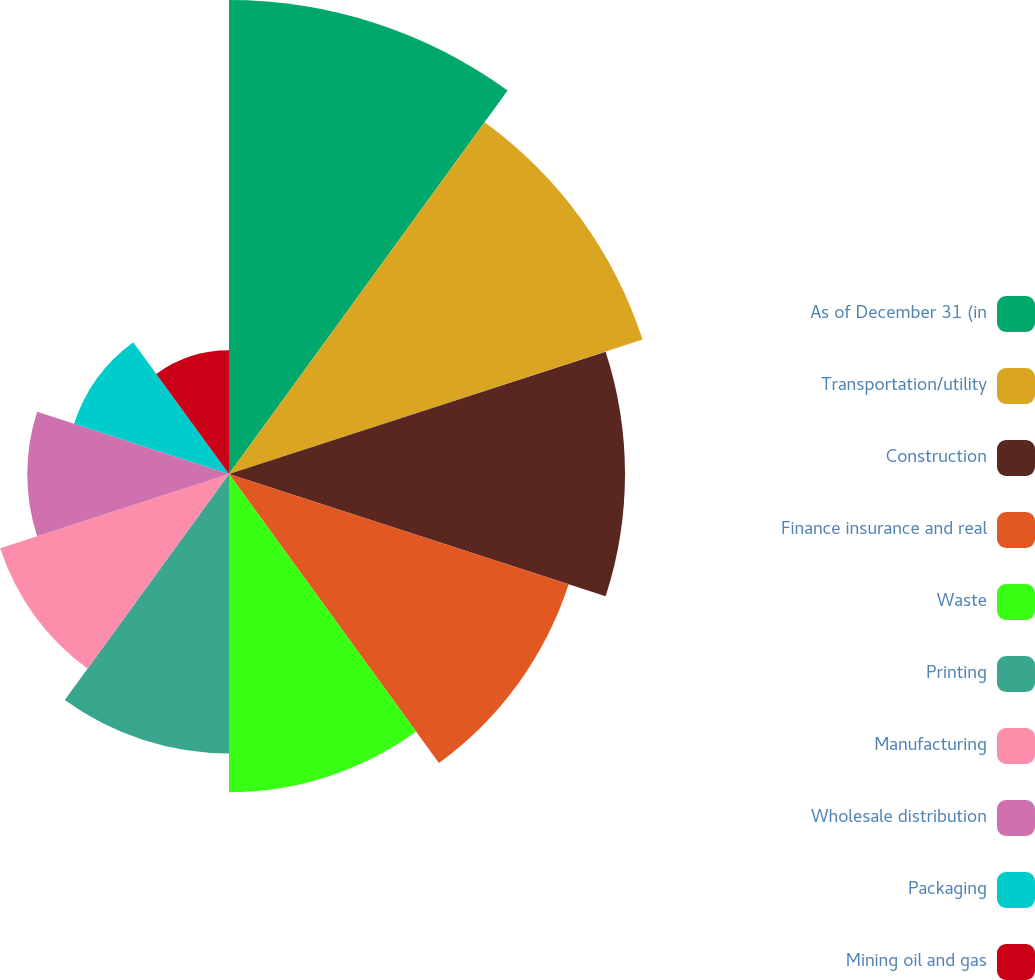Convert chart. <chart><loc_0><loc_0><loc_500><loc_500><pie_chart><fcel>As of December 31 (in<fcel>Transportation/utility<fcel>Construction<fcel>Finance insurance and real<fcel>Waste<fcel>Printing<fcel>Manufacturing<fcel>Wholesale distribution<fcel>Packaging<fcel>Mining oil and gas<nl><fcel>15.86%<fcel>14.55%<fcel>13.25%<fcel>11.95%<fcel>10.65%<fcel>9.35%<fcel>8.05%<fcel>6.75%<fcel>5.45%<fcel>4.14%<nl></chart> 